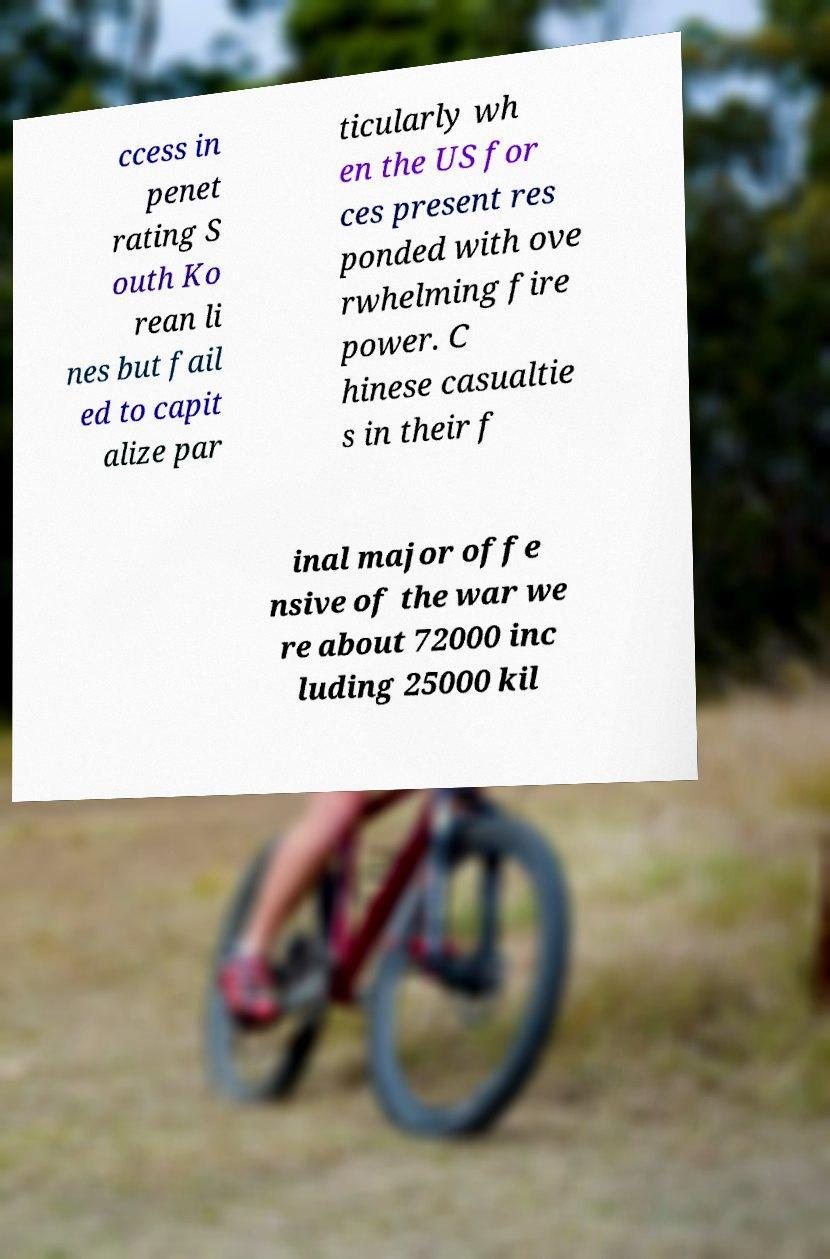Please identify and transcribe the text found in this image. ccess in penet rating S outh Ko rean li nes but fail ed to capit alize par ticularly wh en the US for ces present res ponded with ove rwhelming fire power. C hinese casualtie s in their f inal major offe nsive of the war we re about 72000 inc luding 25000 kil 